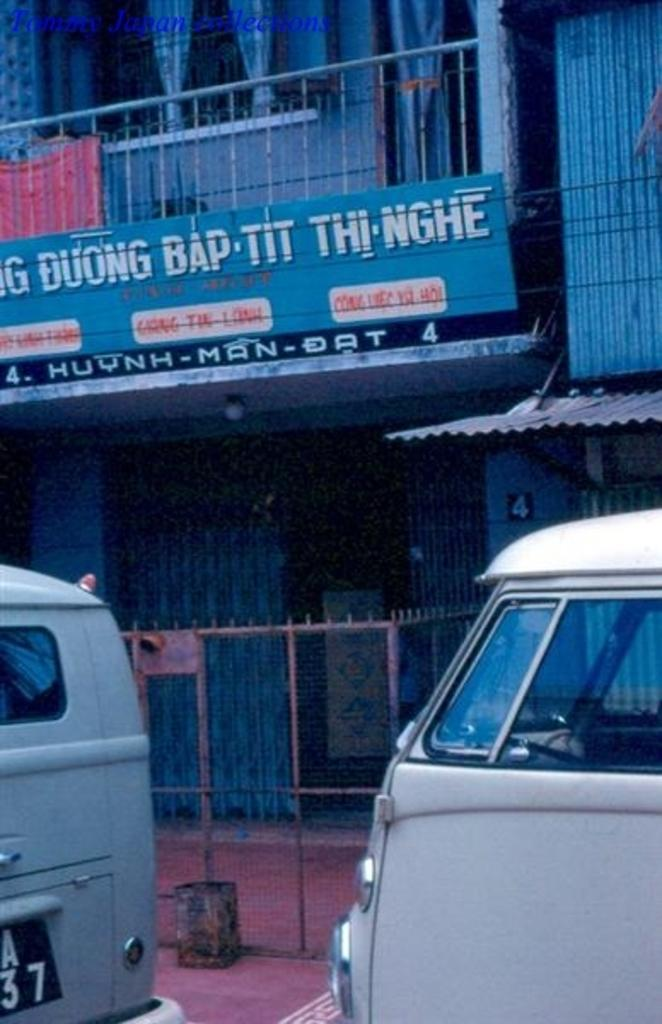How many vehicles can be seen in the image? There are two vehicles in the image. What is located in the background of the image? There is a net fence and a building with railing in the background of the image. Can you describe the board on the building in the background? There is a board on the building in the background of the image, but the facts do not provide any details about its content or purpose. What type of window treatment is visible on the building in the background? There are curtains visible on the building in the background of the image. What type of songs can be heard playing from the toothbrush in the image? There is no toothbrush present in the image, so it is not possible to determine what type of songs might be heard. 